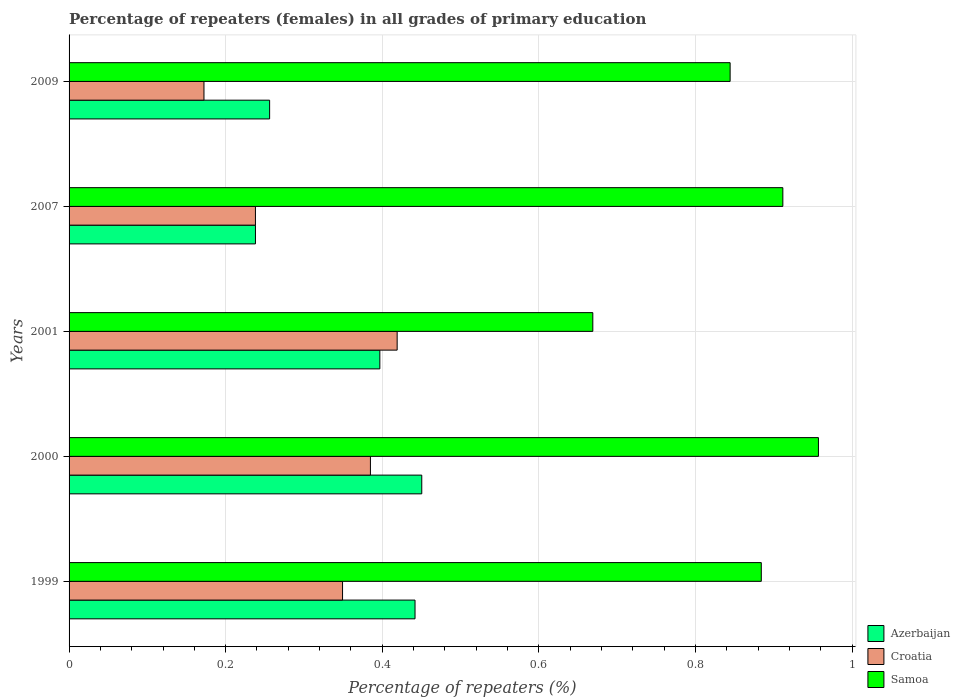How many different coloured bars are there?
Ensure brevity in your answer.  3. How many groups of bars are there?
Your answer should be very brief. 5. Are the number of bars on each tick of the Y-axis equal?
Provide a short and direct response. Yes. What is the percentage of repeaters (females) in Samoa in 2000?
Make the answer very short. 0.96. Across all years, what is the maximum percentage of repeaters (females) in Croatia?
Your answer should be very brief. 0.42. Across all years, what is the minimum percentage of repeaters (females) in Samoa?
Keep it short and to the point. 0.67. What is the total percentage of repeaters (females) in Croatia in the graph?
Ensure brevity in your answer.  1.56. What is the difference between the percentage of repeaters (females) in Croatia in 2007 and that in 2009?
Give a very brief answer. 0.07. What is the difference between the percentage of repeaters (females) in Croatia in 2009 and the percentage of repeaters (females) in Samoa in 2000?
Offer a terse response. -0.78. What is the average percentage of repeaters (females) in Azerbaijan per year?
Your answer should be compact. 0.36. In the year 2000, what is the difference between the percentage of repeaters (females) in Azerbaijan and percentage of repeaters (females) in Samoa?
Offer a terse response. -0.51. In how many years, is the percentage of repeaters (females) in Samoa greater than 0.44 %?
Ensure brevity in your answer.  5. What is the ratio of the percentage of repeaters (females) in Samoa in 1999 to that in 2007?
Make the answer very short. 0.97. Is the percentage of repeaters (females) in Azerbaijan in 1999 less than that in 2001?
Offer a very short reply. No. Is the difference between the percentage of repeaters (females) in Azerbaijan in 2001 and 2009 greater than the difference between the percentage of repeaters (females) in Samoa in 2001 and 2009?
Ensure brevity in your answer.  Yes. What is the difference between the highest and the second highest percentage of repeaters (females) in Croatia?
Offer a terse response. 0.03. What is the difference between the highest and the lowest percentage of repeaters (females) in Samoa?
Offer a terse response. 0.29. Is the sum of the percentage of repeaters (females) in Azerbaijan in 1999 and 2000 greater than the maximum percentage of repeaters (females) in Samoa across all years?
Keep it short and to the point. No. What does the 2nd bar from the top in 2000 represents?
Your answer should be very brief. Croatia. What does the 2nd bar from the bottom in 2001 represents?
Your response must be concise. Croatia. Are all the bars in the graph horizontal?
Give a very brief answer. Yes. How many years are there in the graph?
Your response must be concise. 5. Are the values on the major ticks of X-axis written in scientific E-notation?
Ensure brevity in your answer.  No. Where does the legend appear in the graph?
Provide a succinct answer. Bottom right. How many legend labels are there?
Keep it short and to the point. 3. How are the legend labels stacked?
Your answer should be compact. Vertical. What is the title of the graph?
Your response must be concise. Percentage of repeaters (females) in all grades of primary education. What is the label or title of the X-axis?
Provide a short and direct response. Percentage of repeaters (%). What is the label or title of the Y-axis?
Make the answer very short. Years. What is the Percentage of repeaters (%) of Azerbaijan in 1999?
Keep it short and to the point. 0.44. What is the Percentage of repeaters (%) of Croatia in 1999?
Your answer should be compact. 0.35. What is the Percentage of repeaters (%) in Samoa in 1999?
Provide a short and direct response. 0.88. What is the Percentage of repeaters (%) of Azerbaijan in 2000?
Ensure brevity in your answer.  0.45. What is the Percentage of repeaters (%) of Croatia in 2000?
Give a very brief answer. 0.38. What is the Percentage of repeaters (%) of Samoa in 2000?
Give a very brief answer. 0.96. What is the Percentage of repeaters (%) in Azerbaijan in 2001?
Give a very brief answer. 0.4. What is the Percentage of repeaters (%) in Croatia in 2001?
Ensure brevity in your answer.  0.42. What is the Percentage of repeaters (%) of Samoa in 2001?
Provide a short and direct response. 0.67. What is the Percentage of repeaters (%) in Azerbaijan in 2007?
Keep it short and to the point. 0.24. What is the Percentage of repeaters (%) of Croatia in 2007?
Your answer should be very brief. 0.24. What is the Percentage of repeaters (%) in Samoa in 2007?
Give a very brief answer. 0.91. What is the Percentage of repeaters (%) of Azerbaijan in 2009?
Offer a very short reply. 0.26. What is the Percentage of repeaters (%) in Croatia in 2009?
Keep it short and to the point. 0.17. What is the Percentage of repeaters (%) in Samoa in 2009?
Provide a succinct answer. 0.84. Across all years, what is the maximum Percentage of repeaters (%) of Azerbaijan?
Offer a very short reply. 0.45. Across all years, what is the maximum Percentage of repeaters (%) in Croatia?
Make the answer very short. 0.42. Across all years, what is the maximum Percentage of repeaters (%) of Samoa?
Your answer should be very brief. 0.96. Across all years, what is the minimum Percentage of repeaters (%) of Azerbaijan?
Ensure brevity in your answer.  0.24. Across all years, what is the minimum Percentage of repeaters (%) of Croatia?
Give a very brief answer. 0.17. Across all years, what is the minimum Percentage of repeaters (%) of Samoa?
Ensure brevity in your answer.  0.67. What is the total Percentage of repeaters (%) of Azerbaijan in the graph?
Your answer should be very brief. 1.78. What is the total Percentage of repeaters (%) in Croatia in the graph?
Your answer should be compact. 1.56. What is the total Percentage of repeaters (%) in Samoa in the graph?
Your answer should be very brief. 4.27. What is the difference between the Percentage of repeaters (%) in Azerbaijan in 1999 and that in 2000?
Make the answer very short. -0.01. What is the difference between the Percentage of repeaters (%) in Croatia in 1999 and that in 2000?
Provide a short and direct response. -0.04. What is the difference between the Percentage of repeaters (%) of Samoa in 1999 and that in 2000?
Offer a terse response. -0.07. What is the difference between the Percentage of repeaters (%) in Azerbaijan in 1999 and that in 2001?
Your answer should be compact. 0.04. What is the difference between the Percentage of repeaters (%) of Croatia in 1999 and that in 2001?
Provide a short and direct response. -0.07. What is the difference between the Percentage of repeaters (%) of Samoa in 1999 and that in 2001?
Your answer should be very brief. 0.22. What is the difference between the Percentage of repeaters (%) in Azerbaijan in 1999 and that in 2007?
Give a very brief answer. 0.2. What is the difference between the Percentage of repeaters (%) of Croatia in 1999 and that in 2007?
Your response must be concise. 0.11. What is the difference between the Percentage of repeaters (%) in Samoa in 1999 and that in 2007?
Give a very brief answer. -0.03. What is the difference between the Percentage of repeaters (%) of Azerbaijan in 1999 and that in 2009?
Keep it short and to the point. 0.19. What is the difference between the Percentage of repeaters (%) of Croatia in 1999 and that in 2009?
Provide a succinct answer. 0.18. What is the difference between the Percentage of repeaters (%) of Samoa in 1999 and that in 2009?
Offer a terse response. 0.04. What is the difference between the Percentage of repeaters (%) in Azerbaijan in 2000 and that in 2001?
Keep it short and to the point. 0.05. What is the difference between the Percentage of repeaters (%) of Croatia in 2000 and that in 2001?
Make the answer very short. -0.03. What is the difference between the Percentage of repeaters (%) of Samoa in 2000 and that in 2001?
Offer a terse response. 0.29. What is the difference between the Percentage of repeaters (%) in Azerbaijan in 2000 and that in 2007?
Offer a terse response. 0.21. What is the difference between the Percentage of repeaters (%) in Croatia in 2000 and that in 2007?
Your answer should be compact. 0.15. What is the difference between the Percentage of repeaters (%) of Samoa in 2000 and that in 2007?
Keep it short and to the point. 0.05. What is the difference between the Percentage of repeaters (%) of Azerbaijan in 2000 and that in 2009?
Offer a terse response. 0.19. What is the difference between the Percentage of repeaters (%) of Croatia in 2000 and that in 2009?
Offer a terse response. 0.21. What is the difference between the Percentage of repeaters (%) in Samoa in 2000 and that in 2009?
Offer a very short reply. 0.11. What is the difference between the Percentage of repeaters (%) of Azerbaijan in 2001 and that in 2007?
Ensure brevity in your answer.  0.16. What is the difference between the Percentage of repeaters (%) of Croatia in 2001 and that in 2007?
Your answer should be very brief. 0.18. What is the difference between the Percentage of repeaters (%) in Samoa in 2001 and that in 2007?
Your answer should be compact. -0.24. What is the difference between the Percentage of repeaters (%) in Azerbaijan in 2001 and that in 2009?
Offer a terse response. 0.14. What is the difference between the Percentage of repeaters (%) of Croatia in 2001 and that in 2009?
Offer a very short reply. 0.25. What is the difference between the Percentage of repeaters (%) of Samoa in 2001 and that in 2009?
Give a very brief answer. -0.18. What is the difference between the Percentage of repeaters (%) in Azerbaijan in 2007 and that in 2009?
Provide a short and direct response. -0.02. What is the difference between the Percentage of repeaters (%) in Croatia in 2007 and that in 2009?
Provide a short and direct response. 0.07. What is the difference between the Percentage of repeaters (%) in Samoa in 2007 and that in 2009?
Offer a very short reply. 0.07. What is the difference between the Percentage of repeaters (%) in Azerbaijan in 1999 and the Percentage of repeaters (%) in Croatia in 2000?
Provide a short and direct response. 0.06. What is the difference between the Percentage of repeaters (%) in Azerbaijan in 1999 and the Percentage of repeaters (%) in Samoa in 2000?
Offer a very short reply. -0.52. What is the difference between the Percentage of repeaters (%) in Croatia in 1999 and the Percentage of repeaters (%) in Samoa in 2000?
Give a very brief answer. -0.61. What is the difference between the Percentage of repeaters (%) of Azerbaijan in 1999 and the Percentage of repeaters (%) of Croatia in 2001?
Provide a succinct answer. 0.02. What is the difference between the Percentage of repeaters (%) in Azerbaijan in 1999 and the Percentage of repeaters (%) in Samoa in 2001?
Your answer should be very brief. -0.23. What is the difference between the Percentage of repeaters (%) in Croatia in 1999 and the Percentage of repeaters (%) in Samoa in 2001?
Keep it short and to the point. -0.32. What is the difference between the Percentage of repeaters (%) in Azerbaijan in 1999 and the Percentage of repeaters (%) in Croatia in 2007?
Make the answer very short. 0.2. What is the difference between the Percentage of repeaters (%) of Azerbaijan in 1999 and the Percentage of repeaters (%) of Samoa in 2007?
Provide a short and direct response. -0.47. What is the difference between the Percentage of repeaters (%) in Croatia in 1999 and the Percentage of repeaters (%) in Samoa in 2007?
Keep it short and to the point. -0.56. What is the difference between the Percentage of repeaters (%) of Azerbaijan in 1999 and the Percentage of repeaters (%) of Croatia in 2009?
Ensure brevity in your answer.  0.27. What is the difference between the Percentage of repeaters (%) of Azerbaijan in 1999 and the Percentage of repeaters (%) of Samoa in 2009?
Your answer should be compact. -0.4. What is the difference between the Percentage of repeaters (%) in Croatia in 1999 and the Percentage of repeaters (%) in Samoa in 2009?
Give a very brief answer. -0.49. What is the difference between the Percentage of repeaters (%) of Azerbaijan in 2000 and the Percentage of repeaters (%) of Croatia in 2001?
Your answer should be compact. 0.03. What is the difference between the Percentage of repeaters (%) in Azerbaijan in 2000 and the Percentage of repeaters (%) in Samoa in 2001?
Offer a very short reply. -0.22. What is the difference between the Percentage of repeaters (%) in Croatia in 2000 and the Percentage of repeaters (%) in Samoa in 2001?
Your answer should be compact. -0.28. What is the difference between the Percentage of repeaters (%) of Azerbaijan in 2000 and the Percentage of repeaters (%) of Croatia in 2007?
Your response must be concise. 0.21. What is the difference between the Percentage of repeaters (%) of Azerbaijan in 2000 and the Percentage of repeaters (%) of Samoa in 2007?
Make the answer very short. -0.46. What is the difference between the Percentage of repeaters (%) in Croatia in 2000 and the Percentage of repeaters (%) in Samoa in 2007?
Your answer should be compact. -0.53. What is the difference between the Percentage of repeaters (%) of Azerbaijan in 2000 and the Percentage of repeaters (%) of Croatia in 2009?
Your answer should be very brief. 0.28. What is the difference between the Percentage of repeaters (%) in Azerbaijan in 2000 and the Percentage of repeaters (%) in Samoa in 2009?
Keep it short and to the point. -0.39. What is the difference between the Percentage of repeaters (%) in Croatia in 2000 and the Percentage of repeaters (%) in Samoa in 2009?
Provide a succinct answer. -0.46. What is the difference between the Percentage of repeaters (%) of Azerbaijan in 2001 and the Percentage of repeaters (%) of Croatia in 2007?
Offer a terse response. 0.16. What is the difference between the Percentage of repeaters (%) of Azerbaijan in 2001 and the Percentage of repeaters (%) of Samoa in 2007?
Provide a short and direct response. -0.51. What is the difference between the Percentage of repeaters (%) in Croatia in 2001 and the Percentage of repeaters (%) in Samoa in 2007?
Keep it short and to the point. -0.49. What is the difference between the Percentage of repeaters (%) of Azerbaijan in 2001 and the Percentage of repeaters (%) of Croatia in 2009?
Provide a short and direct response. 0.22. What is the difference between the Percentage of repeaters (%) in Azerbaijan in 2001 and the Percentage of repeaters (%) in Samoa in 2009?
Your answer should be very brief. -0.45. What is the difference between the Percentage of repeaters (%) of Croatia in 2001 and the Percentage of repeaters (%) of Samoa in 2009?
Make the answer very short. -0.43. What is the difference between the Percentage of repeaters (%) of Azerbaijan in 2007 and the Percentage of repeaters (%) of Croatia in 2009?
Ensure brevity in your answer.  0.07. What is the difference between the Percentage of repeaters (%) of Azerbaijan in 2007 and the Percentage of repeaters (%) of Samoa in 2009?
Your response must be concise. -0.61. What is the difference between the Percentage of repeaters (%) in Croatia in 2007 and the Percentage of repeaters (%) in Samoa in 2009?
Keep it short and to the point. -0.61. What is the average Percentage of repeaters (%) of Azerbaijan per year?
Your response must be concise. 0.36. What is the average Percentage of repeaters (%) in Croatia per year?
Give a very brief answer. 0.31. What is the average Percentage of repeaters (%) in Samoa per year?
Make the answer very short. 0.85. In the year 1999, what is the difference between the Percentage of repeaters (%) in Azerbaijan and Percentage of repeaters (%) in Croatia?
Offer a terse response. 0.09. In the year 1999, what is the difference between the Percentage of repeaters (%) in Azerbaijan and Percentage of repeaters (%) in Samoa?
Offer a terse response. -0.44. In the year 1999, what is the difference between the Percentage of repeaters (%) of Croatia and Percentage of repeaters (%) of Samoa?
Offer a very short reply. -0.53. In the year 2000, what is the difference between the Percentage of repeaters (%) of Azerbaijan and Percentage of repeaters (%) of Croatia?
Give a very brief answer. 0.07. In the year 2000, what is the difference between the Percentage of repeaters (%) of Azerbaijan and Percentage of repeaters (%) of Samoa?
Provide a short and direct response. -0.51. In the year 2000, what is the difference between the Percentage of repeaters (%) in Croatia and Percentage of repeaters (%) in Samoa?
Your answer should be compact. -0.57. In the year 2001, what is the difference between the Percentage of repeaters (%) in Azerbaijan and Percentage of repeaters (%) in Croatia?
Ensure brevity in your answer.  -0.02. In the year 2001, what is the difference between the Percentage of repeaters (%) in Azerbaijan and Percentage of repeaters (%) in Samoa?
Provide a short and direct response. -0.27. In the year 2001, what is the difference between the Percentage of repeaters (%) in Croatia and Percentage of repeaters (%) in Samoa?
Your answer should be very brief. -0.25. In the year 2007, what is the difference between the Percentage of repeaters (%) of Azerbaijan and Percentage of repeaters (%) of Samoa?
Give a very brief answer. -0.67. In the year 2007, what is the difference between the Percentage of repeaters (%) in Croatia and Percentage of repeaters (%) in Samoa?
Provide a succinct answer. -0.67. In the year 2009, what is the difference between the Percentage of repeaters (%) of Azerbaijan and Percentage of repeaters (%) of Croatia?
Make the answer very short. 0.08. In the year 2009, what is the difference between the Percentage of repeaters (%) in Azerbaijan and Percentage of repeaters (%) in Samoa?
Ensure brevity in your answer.  -0.59. In the year 2009, what is the difference between the Percentage of repeaters (%) of Croatia and Percentage of repeaters (%) of Samoa?
Provide a short and direct response. -0.67. What is the ratio of the Percentage of repeaters (%) in Azerbaijan in 1999 to that in 2000?
Keep it short and to the point. 0.98. What is the ratio of the Percentage of repeaters (%) of Croatia in 1999 to that in 2000?
Your answer should be compact. 0.91. What is the ratio of the Percentage of repeaters (%) in Samoa in 1999 to that in 2000?
Keep it short and to the point. 0.92. What is the ratio of the Percentage of repeaters (%) in Azerbaijan in 1999 to that in 2001?
Keep it short and to the point. 1.11. What is the ratio of the Percentage of repeaters (%) in Croatia in 1999 to that in 2001?
Make the answer very short. 0.83. What is the ratio of the Percentage of repeaters (%) in Samoa in 1999 to that in 2001?
Provide a short and direct response. 1.32. What is the ratio of the Percentage of repeaters (%) in Azerbaijan in 1999 to that in 2007?
Offer a terse response. 1.86. What is the ratio of the Percentage of repeaters (%) of Croatia in 1999 to that in 2007?
Provide a short and direct response. 1.47. What is the ratio of the Percentage of repeaters (%) of Samoa in 1999 to that in 2007?
Make the answer very short. 0.97. What is the ratio of the Percentage of repeaters (%) of Azerbaijan in 1999 to that in 2009?
Keep it short and to the point. 1.73. What is the ratio of the Percentage of repeaters (%) in Croatia in 1999 to that in 2009?
Your answer should be compact. 2.03. What is the ratio of the Percentage of repeaters (%) in Samoa in 1999 to that in 2009?
Keep it short and to the point. 1.05. What is the ratio of the Percentage of repeaters (%) of Azerbaijan in 2000 to that in 2001?
Offer a very short reply. 1.13. What is the ratio of the Percentage of repeaters (%) of Croatia in 2000 to that in 2001?
Your response must be concise. 0.92. What is the ratio of the Percentage of repeaters (%) in Samoa in 2000 to that in 2001?
Your answer should be compact. 1.43. What is the ratio of the Percentage of repeaters (%) of Azerbaijan in 2000 to that in 2007?
Make the answer very short. 1.89. What is the ratio of the Percentage of repeaters (%) in Croatia in 2000 to that in 2007?
Offer a terse response. 1.62. What is the ratio of the Percentage of repeaters (%) of Samoa in 2000 to that in 2007?
Give a very brief answer. 1.05. What is the ratio of the Percentage of repeaters (%) in Azerbaijan in 2000 to that in 2009?
Ensure brevity in your answer.  1.76. What is the ratio of the Percentage of repeaters (%) in Croatia in 2000 to that in 2009?
Your answer should be very brief. 2.23. What is the ratio of the Percentage of repeaters (%) in Samoa in 2000 to that in 2009?
Keep it short and to the point. 1.13. What is the ratio of the Percentage of repeaters (%) of Azerbaijan in 2001 to that in 2007?
Your answer should be very brief. 1.67. What is the ratio of the Percentage of repeaters (%) of Croatia in 2001 to that in 2007?
Keep it short and to the point. 1.76. What is the ratio of the Percentage of repeaters (%) in Samoa in 2001 to that in 2007?
Your answer should be compact. 0.73. What is the ratio of the Percentage of repeaters (%) in Azerbaijan in 2001 to that in 2009?
Offer a very short reply. 1.55. What is the ratio of the Percentage of repeaters (%) of Croatia in 2001 to that in 2009?
Provide a short and direct response. 2.43. What is the ratio of the Percentage of repeaters (%) of Samoa in 2001 to that in 2009?
Your answer should be very brief. 0.79. What is the ratio of the Percentage of repeaters (%) of Azerbaijan in 2007 to that in 2009?
Provide a succinct answer. 0.93. What is the ratio of the Percentage of repeaters (%) in Croatia in 2007 to that in 2009?
Your response must be concise. 1.38. What is the ratio of the Percentage of repeaters (%) in Samoa in 2007 to that in 2009?
Give a very brief answer. 1.08. What is the difference between the highest and the second highest Percentage of repeaters (%) in Azerbaijan?
Make the answer very short. 0.01. What is the difference between the highest and the second highest Percentage of repeaters (%) in Croatia?
Your answer should be compact. 0.03. What is the difference between the highest and the second highest Percentage of repeaters (%) of Samoa?
Make the answer very short. 0.05. What is the difference between the highest and the lowest Percentage of repeaters (%) of Azerbaijan?
Your response must be concise. 0.21. What is the difference between the highest and the lowest Percentage of repeaters (%) in Croatia?
Give a very brief answer. 0.25. What is the difference between the highest and the lowest Percentage of repeaters (%) of Samoa?
Provide a succinct answer. 0.29. 